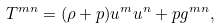Convert formula to latex. <formula><loc_0><loc_0><loc_500><loc_500>T ^ { m n } = ( \rho + p ) u ^ { m } u ^ { n } + p g ^ { m n } ,</formula> 